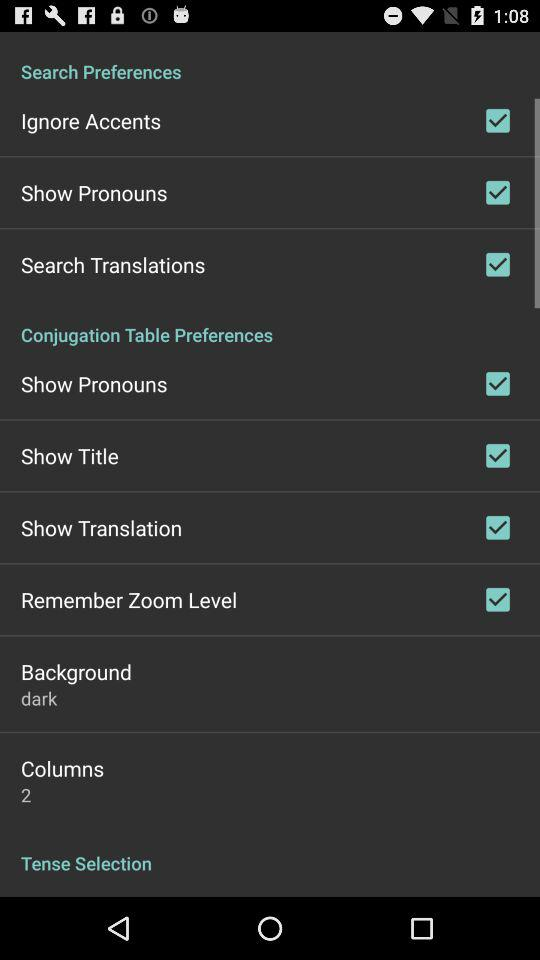What is the selected number of columns? The selected number of columns is 2. 